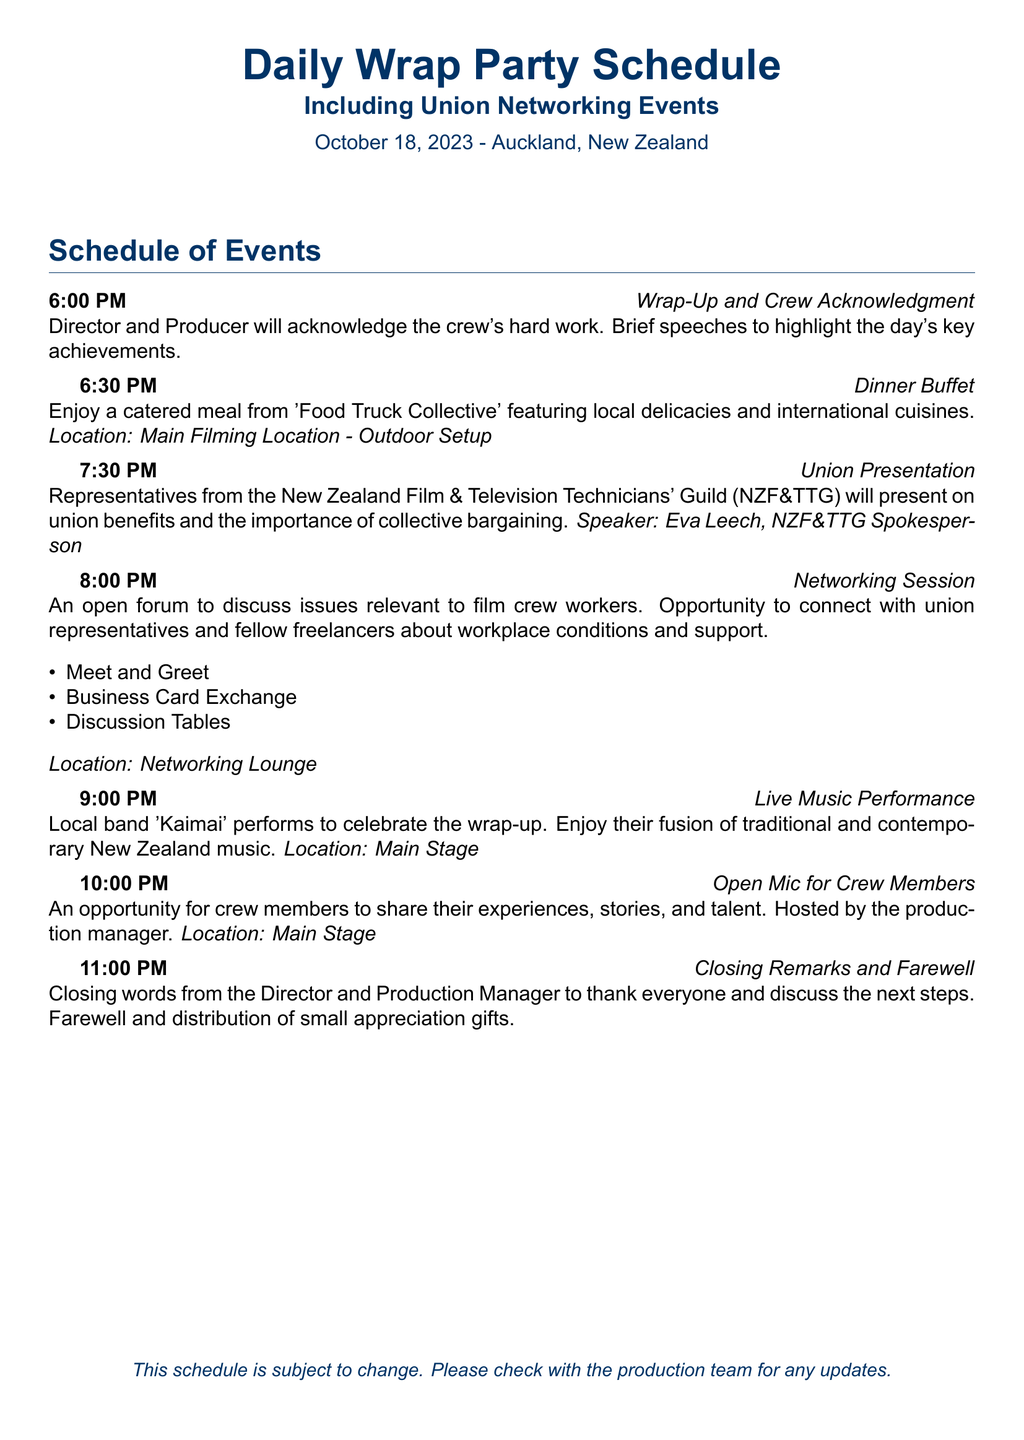What is the date of the event? The date of the event is explicitly stated at the top of the document.
Answer: October 18, 2023 Who is the speaker for the Union Presentation? The document mentions the speaker in the context of the Union Presentation section.
Answer: Eva Leech What time does the Dinner Buffet start? The document lists the starting time for each event, including Dinner Buffet.
Answer: 6:30 PM What type of cuisine is offered at the Dinner Buffet? The document describes the meal's nature and origin in the Dinner Buffet section.
Answer: Local delicacies and international cuisines What is the location for the Networking Session? The document includes the location for each event, specifically for the Networking Session.
Answer: Networking Lounge What activity is scheduled right after the Union Presentation? The order of events is outlined, indicating what follows after the Union Presentation.
Answer: Networking Session How long is the Live Music Performance scheduled for? The document lists the duration of all events, to infer the length of the Live Music Performance based on the times provided in the schedule.
Answer: 1 hour What is provided to crew members during the Closing Remarks? The document mentions the farewells and gifts associated with the Closing Remarks.
Answer: Small appreciation gifts 